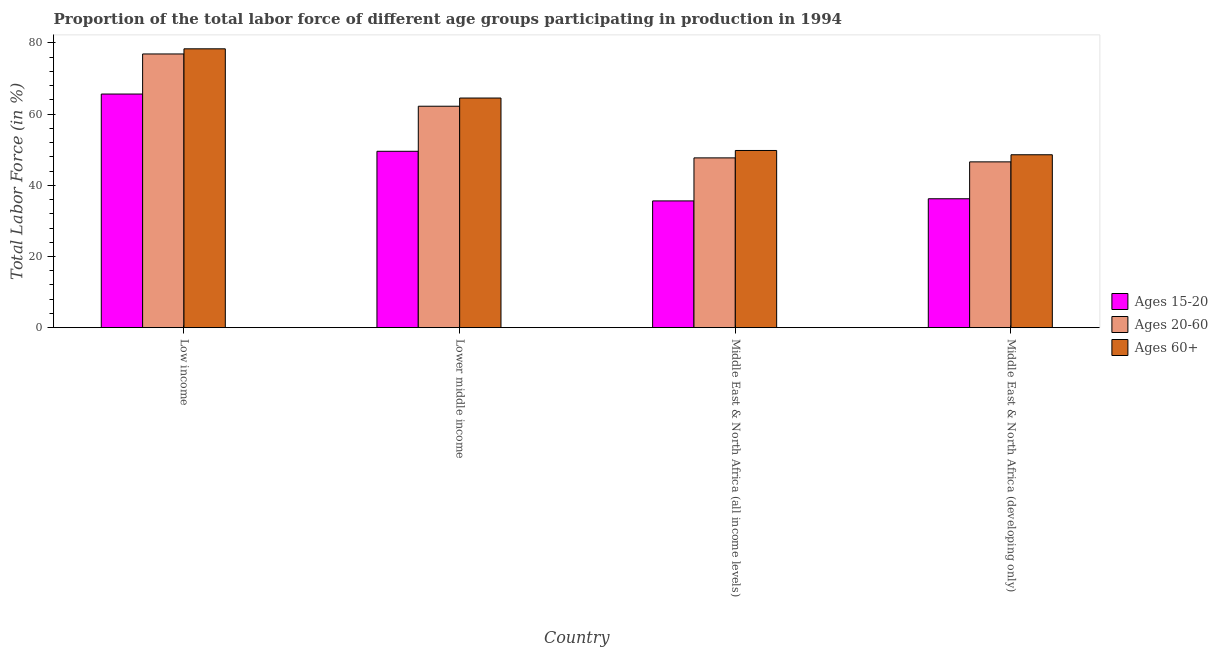Are the number of bars per tick equal to the number of legend labels?
Ensure brevity in your answer.  Yes. What is the label of the 1st group of bars from the left?
Your response must be concise. Low income. What is the percentage of labor force above age 60 in Middle East & North Africa (all income levels)?
Offer a terse response. 49.79. Across all countries, what is the maximum percentage of labor force within the age group 20-60?
Offer a very short reply. 76.92. Across all countries, what is the minimum percentage of labor force within the age group 20-60?
Make the answer very short. 46.59. In which country was the percentage of labor force above age 60 maximum?
Make the answer very short. Low income. In which country was the percentage of labor force within the age group 15-20 minimum?
Make the answer very short. Middle East & North Africa (all income levels). What is the total percentage of labor force within the age group 20-60 in the graph?
Your answer should be compact. 233.45. What is the difference between the percentage of labor force within the age group 15-20 in Low income and that in Lower middle income?
Make the answer very short. 16.09. What is the difference between the percentage of labor force within the age group 15-20 in Lower middle income and the percentage of labor force above age 60 in Low income?
Offer a very short reply. -28.8. What is the average percentage of labor force above age 60 per country?
Your answer should be very brief. 60.32. What is the difference between the percentage of labor force within the age group 20-60 and percentage of labor force within the age group 15-20 in Middle East & North Africa (developing only)?
Ensure brevity in your answer.  10.37. In how many countries, is the percentage of labor force above age 60 greater than 24 %?
Keep it short and to the point. 4. What is the ratio of the percentage of labor force within the age group 15-20 in Low income to that in Middle East & North Africa (developing only)?
Keep it short and to the point. 1.81. Is the percentage of labor force within the age group 15-20 in Low income less than that in Middle East & North Africa (developing only)?
Ensure brevity in your answer.  No. What is the difference between the highest and the second highest percentage of labor force within the age group 20-60?
Offer a very short reply. 14.69. What is the difference between the highest and the lowest percentage of labor force within the age group 20-60?
Your response must be concise. 30.32. In how many countries, is the percentage of labor force within the age group 20-60 greater than the average percentage of labor force within the age group 20-60 taken over all countries?
Keep it short and to the point. 2. Is the sum of the percentage of labor force above age 60 in Low income and Middle East & North Africa (all income levels) greater than the maximum percentage of labor force within the age group 20-60 across all countries?
Provide a succinct answer. Yes. What does the 3rd bar from the left in Low income represents?
Provide a short and direct response. Ages 60+. What does the 1st bar from the right in Lower middle income represents?
Give a very brief answer. Ages 60+. How many bars are there?
Your response must be concise. 12. Are all the bars in the graph horizontal?
Your answer should be very brief. No. Does the graph contain grids?
Your answer should be compact. No. Where does the legend appear in the graph?
Provide a succinct answer. Center right. How many legend labels are there?
Provide a succinct answer. 3. How are the legend labels stacked?
Provide a succinct answer. Vertical. What is the title of the graph?
Your response must be concise. Proportion of the total labor force of different age groups participating in production in 1994. Does "Tertiary education" appear as one of the legend labels in the graph?
Your response must be concise. No. What is the label or title of the X-axis?
Give a very brief answer. Country. What is the Total Labor Force (in %) in Ages 15-20 in Low income?
Offer a terse response. 65.65. What is the Total Labor Force (in %) of Ages 20-60 in Low income?
Your response must be concise. 76.92. What is the Total Labor Force (in %) in Ages 60+ in Low income?
Give a very brief answer. 78.36. What is the Total Labor Force (in %) in Ages 15-20 in Lower middle income?
Make the answer very short. 49.56. What is the Total Labor Force (in %) in Ages 20-60 in Lower middle income?
Give a very brief answer. 62.23. What is the Total Labor Force (in %) in Ages 60+ in Lower middle income?
Your answer should be compact. 64.53. What is the Total Labor Force (in %) of Ages 15-20 in Middle East & North Africa (all income levels)?
Your response must be concise. 35.62. What is the Total Labor Force (in %) of Ages 20-60 in Middle East & North Africa (all income levels)?
Provide a short and direct response. 47.71. What is the Total Labor Force (in %) of Ages 60+ in Middle East & North Africa (all income levels)?
Your answer should be very brief. 49.79. What is the Total Labor Force (in %) in Ages 15-20 in Middle East & North Africa (developing only)?
Your response must be concise. 36.23. What is the Total Labor Force (in %) of Ages 20-60 in Middle East & North Africa (developing only)?
Provide a short and direct response. 46.59. What is the Total Labor Force (in %) in Ages 60+ in Middle East & North Africa (developing only)?
Give a very brief answer. 48.59. Across all countries, what is the maximum Total Labor Force (in %) of Ages 15-20?
Your response must be concise. 65.65. Across all countries, what is the maximum Total Labor Force (in %) in Ages 20-60?
Your answer should be very brief. 76.92. Across all countries, what is the maximum Total Labor Force (in %) in Ages 60+?
Ensure brevity in your answer.  78.36. Across all countries, what is the minimum Total Labor Force (in %) in Ages 15-20?
Offer a terse response. 35.62. Across all countries, what is the minimum Total Labor Force (in %) of Ages 20-60?
Your answer should be very brief. 46.59. Across all countries, what is the minimum Total Labor Force (in %) of Ages 60+?
Offer a very short reply. 48.59. What is the total Total Labor Force (in %) of Ages 15-20 in the graph?
Your answer should be very brief. 187.06. What is the total Total Labor Force (in %) of Ages 20-60 in the graph?
Your answer should be very brief. 233.45. What is the total Total Labor Force (in %) of Ages 60+ in the graph?
Your response must be concise. 241.27. What is the difference between the Total Labor Force (in %) of Ages 15-20 in Low income and that in Lower middle income?
Your answer should be compact. 16.09. What is the difference between the Total Labor Force (in %) of Ages 20-60 in Low income and that in Lower middle income?
Your answer should be compact. 14.69. What is the difference between the Total Labor Force (in %) of Ages 60+ in Low income and that in Lower middle income?
Offer a terse response. 13.83. What is the difference between the Total Labor Force (in %) in Ages 15-20 in Low income and that in Middle East & North Africa (all income levels)?
Keep it short and to the point. 30.03. What is the difference between the Total Labor Force (in %) of Ages 20-60 in Low income and that in Middle East & North Africa (all income levels)?
Keep it short and to the point. 29.21. What is the difference between the Total Labor Force (in %) of Ages 60+ in Low income and that in Middle East & North Africa (all income levels)?
Ensure brevity in your answer.  28.57. What is the difference between the Total Labor Force (in %) of Ages 15-20 in Low income and that in Middle East & North Africa (developing only)?
Ensure brevity in your answer.  29.43. What is the difference between the Total Labor Force (in %) in Ages 20-60 in Low income and that in Middle East & North Africa (developing only)?
Ensure brevity in your answer.  30.32. What is the difference between the Total Labor Force (in %) in Ages 60+ in Low income and that in Middle East & North Africa (developing only)?
Offer a terse response. 29.77. What is the difference between the Total Labor Force (in %) in Ages 15-20 in Lower middle income and that in Middle East & North Africa (all income levels)?
Keep it short and to the point. 13.94. What is the difference between the Total Labor Force (in %) of Ages 20-60 in Lower middle income and that in Middle East & North Africa (all income levels)?
Offer a terse response. 14.52. What is the difference between the Total Labor Force (in %) of Ages 60+ in Lower middle income and that in Middle East & North Africa (all income levels)?
Make the answer very short. 14.74. What is the difference between the Total Labor Force (in %) in Ages 15-20 in Lower middle income and that in Middle East & North Africa (developing only)?
Make the answer very short. 13.34. What is the difference between the Total Labor Force (in %) in Ages 20-60 in Lower middle income and that in Middle East & North Africa (developing only)?
Make the answer very short. 15.64. What is the difference between the Total Labor Force (in %) of Ages 60+ in Lower middle income and that in Middle East & North Africa (developing only)?
Offer a terse response. 15.94. What is the difference between the Total Labor Force (in %) in Ages 15-20 in Middle East & North Africa (all income levels) and that in Middle East & North Africa (developing only)?
Your answer should be compact. -0.61. What is the difference between the Total Labor Force (in %) in Ages 20-60 in Middle East & North Africa (all income levels) and that in Middle East & North Africa (developing only)?
Your answer should be compact. 1.12. What is the difference between the Total Labor Force (in %) of Ages 60+ in Middle East & North Africa (all income levels) and that in Middle East & North Africa (developing only)?
Your answer should be compact. 1.21. What is the difference between the Total Labor Force (in %) in Ages 15-20 in Low income and the Total Labor Force (in %) in Ages 20-60 in Lower middle income?
Keep it short and to the point. 3.42. What is the difference between the Total Labor Force (in %) in Ages 15-20 in Low income and the Total Labor Force (in %) in Ages 60+ in Lower middle income?
Ensure brevity in your answer.  1.12. What is the difference between the Total Labor Force (in %) of Ages 20-60 in Low income and the Total Labor Force (in %) of Ages 60+ in Lower middle income?
Your answer should be compact. 12.39. What is the difference between the Total Labor Force (in %) of Ages 15-20 in Low income and the Total Labor Force (in %) of Ages 20-60 in Middle East & North Africa (all income levels)?
Give a very brief answer. 17.94. What is the difference between the Total Labor Force (in %) in Ages 15-20 in Low income and the Total Labor Force (in %) in Ages 60+ in Middle East & North Africa (all income levels)?
Keep it short and to the point. 15.86. What is the difference between the Total Labor Force (in %) in Ages 20-60 in Low income and the Total Labor Force (in %) in Ages 60+ in Middle East & North Africa (all income levels)?
Your response must be concise. 27.12. What is the difference between the Total Labor Force (in %) of Ages 15-20 in Low income and the Total Labor Force (in %) of Ages 20-60 in Middle East & North Africa (developing only)?
Offer a terse response. 19.06. What is the difference between the Total Labor Force (in %) in Ages 15-20 in Low income and the Total Labor Force (in %) in Ages 60+ in Middle East & North Africa (developing only)?
Offer a terse response. 17.06. What is the difference between the Total Labor Force (in %) in Ages 20-60 in Low income and the Total Labor Force (in %) in Ages 60+ in Middle East & North Africa (developing only)?
Offer a terse response. 28.33. What is the difference between the Total Labor Force (in %) in Ages 15-20 in Lower middle income and the Total Labor Force (in %) in Ages 20-60 in Middle East & North Africa (all income levels)?
Offer a very short reply. 1.85. What is the difference between the Total Labor Force (in %) in Ages 15-20 in Lower middle income and the Total Labor Force (in %) in Ages 60+ in Middle East & North Africa (all income levels)?
Provide a short and direct response. -0.23. What is the difference between the Total Labor Force (in %) of Ages 20-60 in Lower middle income and the Total Labor Force (in %) of Ages 60+ in Middle East & North Africa (all income levels)?
Ensure brevity in your answer.  12.44. What is the difference between the Total Labor Force (in %) of Ages 15-20 in Lower middle income and the Total Labor Force (in %) of Ages 20-60 in Middle East & North Africa (developing only)?
Your answer should be very brief. 2.97. What is the difference between the Total Labor Force (in %) in Ages 15-20 in Lower middle income and the Total Labor Force (in %) in Ages 60+ in Middle East & North Africa (developing only)?
Offer a terse response. 0.97. What is the difference between the Total Labor Force (in %) in Ages 20-60 in Lower middle income and the Total Labor Force (in %) in Ages 60+ in Middle East & North Africa (developing only)?
Your answer should be very brief. 13.64. What is the difference between the Total Labor Force (in %) of Ages 15-20 in Middle East & North Africa (all income levels) and the Total Labor Force (in %) of Ages 20-60 in Middle East & North Africa (developing only)?
Keep it short and to the point. -10.97. What is the difference between the Total Labor Force (in %) of Ages 15-20 in Middle East & North Africa (all income levels) and the Total Labor Force (in %) of Ages 60+ in Middle East & North Africa (developing only)?
Provide a short and direct response. -12.97. What is the difference between the Total Labor Force (in %) of Ages 20-60 in Middle East & North Africa (all income levels) and the Total Labor Force (in %) of Ages 60+ in Middle East & North Africa (developing only)?
Your answer should be very brief. -0.88. What is the average Total Labor Force (in %) in Ages 15-20 per country?
Keep it short and to the point. 46.77. What is the average Total Labor Force (in %) of Ages 20-60 per country?
Offer a terse response. 58.36. What is the average Total Labor Force (in %) in Ages 60+ per country?
Offer a very short reply. 60.32. What is the difference between the Total Labor Force (in %) of Ages 15-20 and Total Labor Force (in %) of Ages 20-60 in Low income?
Ensure brevity in your answer.  -11.26. What is the difference between the Total Labor Force (in %) of Ages 15-20 and Total Labor Force (in %) of Ages 60+ in Low income?
Provide a short and direct response. -12.71. What is the difference between the Total Labor Force (in %) of Ages 20-60 and Total Labor Force (in %) of Ages 60+ in Low income?
Keep it short and to the point. -1.44. What is the difference between the Total Labor Force (in %) of Ages 15-20 and Total Labor Force (in %) of Ages 20-60 in Lower middle income?
Offer a terse response. -12.67. What is the difference between the Total Labor Force (in %) in Ages 15-20 and Total Labor Force (in %) in Ages 60+ in Lower middle income?
Your answer should be very brief. -14.97. What is the difference between the Total Labor Force (in %) of Ages 20-60 and Total Labor Force (in %) of Ages 60+ in Lower middle income?
Your answer should be very brief. -2.3. What is the difference between the Total Labor Force (in %) in Ages 15-20 and Total Labor Force (in %) in Ages 20-60 in Middle East & North Africa (all income levels)?
Ensure brevity in your answer.  -12.09. What is the difference between the Total Labor Force (in %) of Ages 15-20 and Total Labor Force (in %) of Ages 60+ in Middle East & North Africa (all income levels)?
Your response must be concise. -14.17. What is the difference between the Total Labor Force (in %) in Ages 20-60 and Total Labor Force (in %) in Ages 60+ in Middle East & North Africa (all income levels)?
Provide a short and direct response. -2.08. What is the difference between the Total Labor Force (in %) of Ages 15-20 and Total Labor Force (in %) of Ages 20-60 in Middle East & North Africa (developing only)?
Your answer should be compact. -10.37. What is the difference between the Total Labor Force (in %) in Ages 15-20 and Total Labor Force (in %) in Ages 60+ in Middle East & North Africa (developing only)?
Provide a short and direct response. -12.36. What is the difference between the Total Labor Force (in %) in Ages 20-60 and Total Labor Force (in %) in Ages 60+ in Middle East & North Africa (developing only)?
Ensure brevity in your answer.  -2. What is the ratio of the Total Labor Force (in %) of Ages 15-20 in Low income to that in Lower middle income?
Keep it short and to the point. 1.32. What is the ratio of the Total Labor Force (in %) in Ages 20-60 in Low income to that in Lower middle income?
Provide a short and direct response. 1.24. What is the ratio of the Total Labor Force (in %) in Ages 60+ in Low income to that in Lower middle income?
Offer a very short reply. 1.21. What is the ratio of the Total Labor Force (in %) of Ages 15-20 in Low income to that in Middle East & North Africa (all income levels)?
Your answer should be very brief. 1.84. What is the ratio of the Total Labor Force (in %) in Ages 20-60 in Low income to that in Middle East & North Africa (all income levels)?
Offer a very short reply. 1.61. What is the ratio of the Total Labor Force (in %) in Ages 60+ in Low income to that in Middle East & North Africa (all income levels)?
Provide a succinct answer. 1.57. What is the ratio of the Total Labor Force (in %) in Ages 15-20 in Low income to that in Middle East & North Africa (developing only)?
Ensure brevity in your answer.  1.81. What is the ratio of the Total Labor Force (in %) in Ages 20-60 in Low income to that in Middle East & North Africa (developing only)?
Keep it short and to the point. 1.65. What is the ratio of the Total Labor Force (in %) in Ages 60+ in Low income to that in Middle East & North Africa (developing only)?
Make the answer very short. 1.61. What is the ratio of the Total Labor Force (in %) of Ages 15-20 in Lower middle income to that in Middle East & North Africa (all income levels)?
Provide a succinct answer. 1.39. What is the ratio of the Total Labor Force (in %) in Ages 20-60 in Lower middle income to that in Middle East & North Africa (all income levels)?
Provide a short and direct response. 1.3. What is the ratio of the Total Labor Force (in %) of Ages 60+ in Lower middle income to that in Middle East & North Africa (all income levels)?
Offer a very short reply. 1.3. What is the ratio of the Total Labor Force (in %) in Ages 15-20 in Lower middle income to that in Middle East & North Africa (developing only)?
Provide a succinct answer. 1.37. What is the ratio of the Total Labor Force (in %) of Ages 20-60 in Lower middle income to that in Middle East & North Africa (developing only)?
Give a very brief answer. 1.34. What is the ratio of the Total Labor Force (in %) of Ages 60+ in Lower middle income to that in Middle East & North Africa (developing only)?
Provide a short and direct response. 1.33. What is the ratio of the Total Labor Force (in %) in Ages 15-20 in Middle East & North Africa (all income levels) to that in Middle East & North Africa (developing only)?
Provide a short and direct response. 0.98. What is the ratio of the Total Labor Force (in %) of Ages 60+ in Middle East & North Africa (all income levels) to that in Middle East & North Africa (developing only)?
Ensure brevity in your answer.  1.02. What is the difference between the highest and the second highest Total Labor Force (in %) in Ages 15-20?
Your answer should be compact. 16.09. What is the difference between the highest and the second highest Total Labor Force (in %) of Ages 20-60?
Make the answer very short. 14.69. What is the difference between the highest and the second highest Total Labor Force (in %) of Ages 60+?
Keep it short and to the point. 13.83. What is the difference between the highest and the lowest Total Labor Force (in %) of Ages 15-20?
Give a very brief answer. 30.03. What is the difference between the highest and the lowest Total Labor Force (in %) in Ages 20-60?
Ensure brevity in your answer.  30.32. What is the difference between the highest and the lowest Total Labor Force (in %) in Ages 60+?
Offer a very short reply. 29.77. 